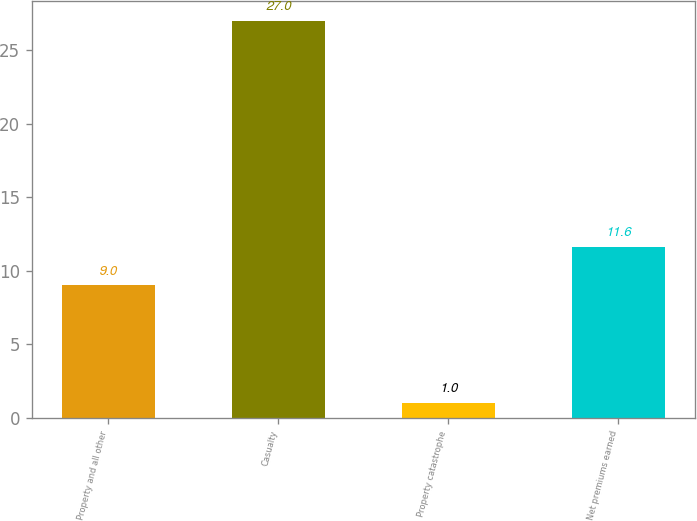Convert chart. <chart><loc_0><loc_0><loc_500><loc_500><bar_chart><fcel>Property and all other<fcel>Casualty<fcel>Property catastrophe<fcel>Net premiums earned<nl><fcel>9<fcel>27<fcel>1<fcel>11.6<nl></chart> 